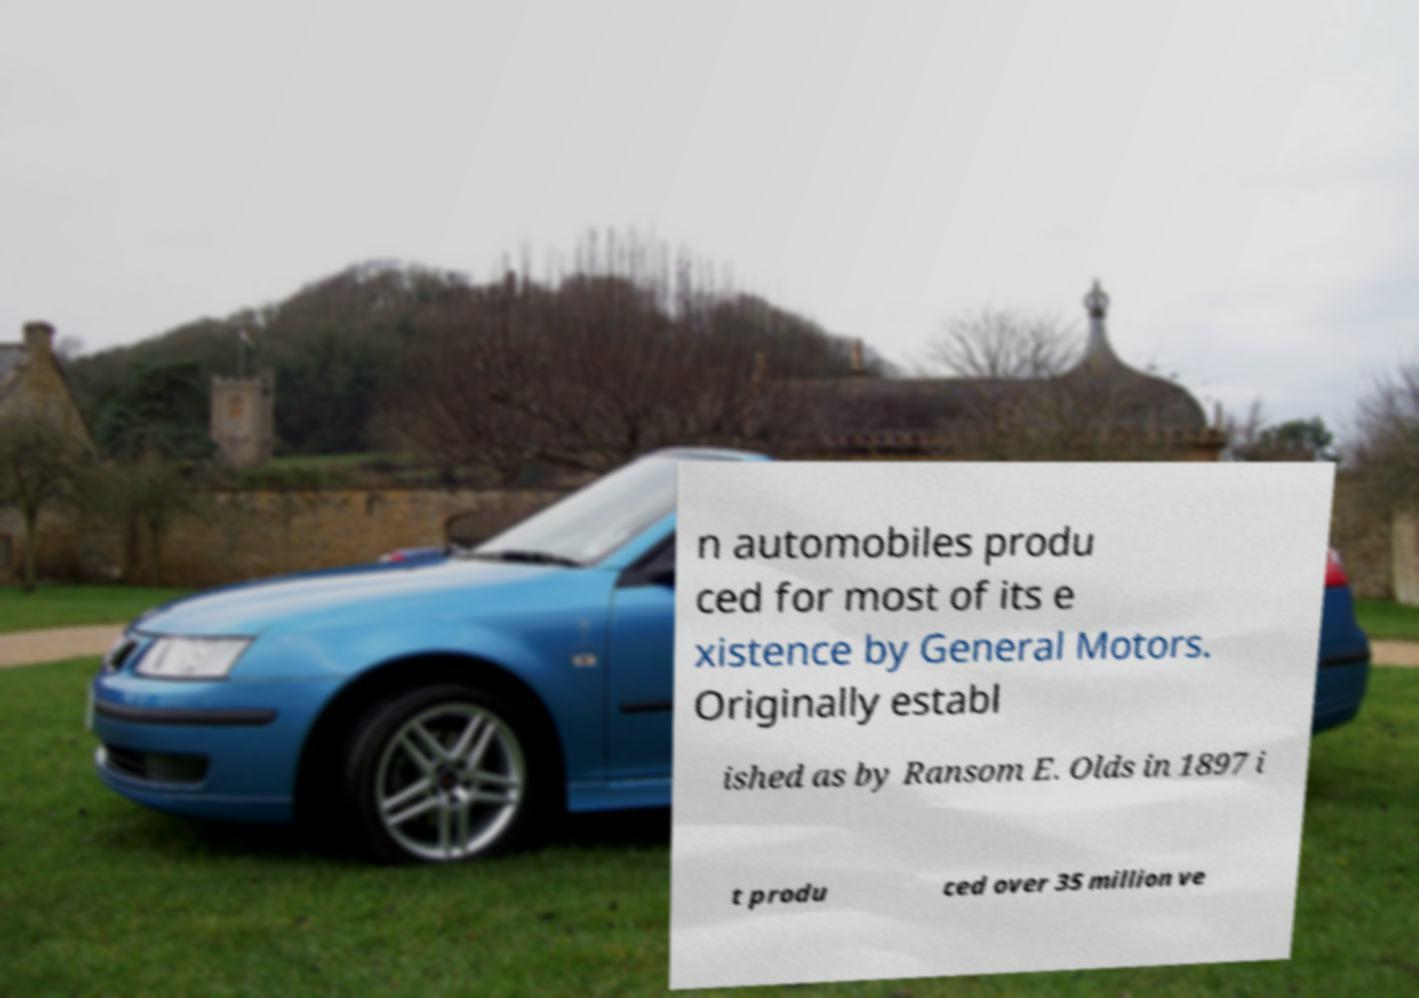Can you read and provide the text displayed in the image?This photo seems to have some interesting text. Can you extract and type it out for me? n automobiles produ ced for most of its e xistence by General Motors. Originally establ ished as by Ransom E. Olds in 1897 i t produ ced over 35 million ve 